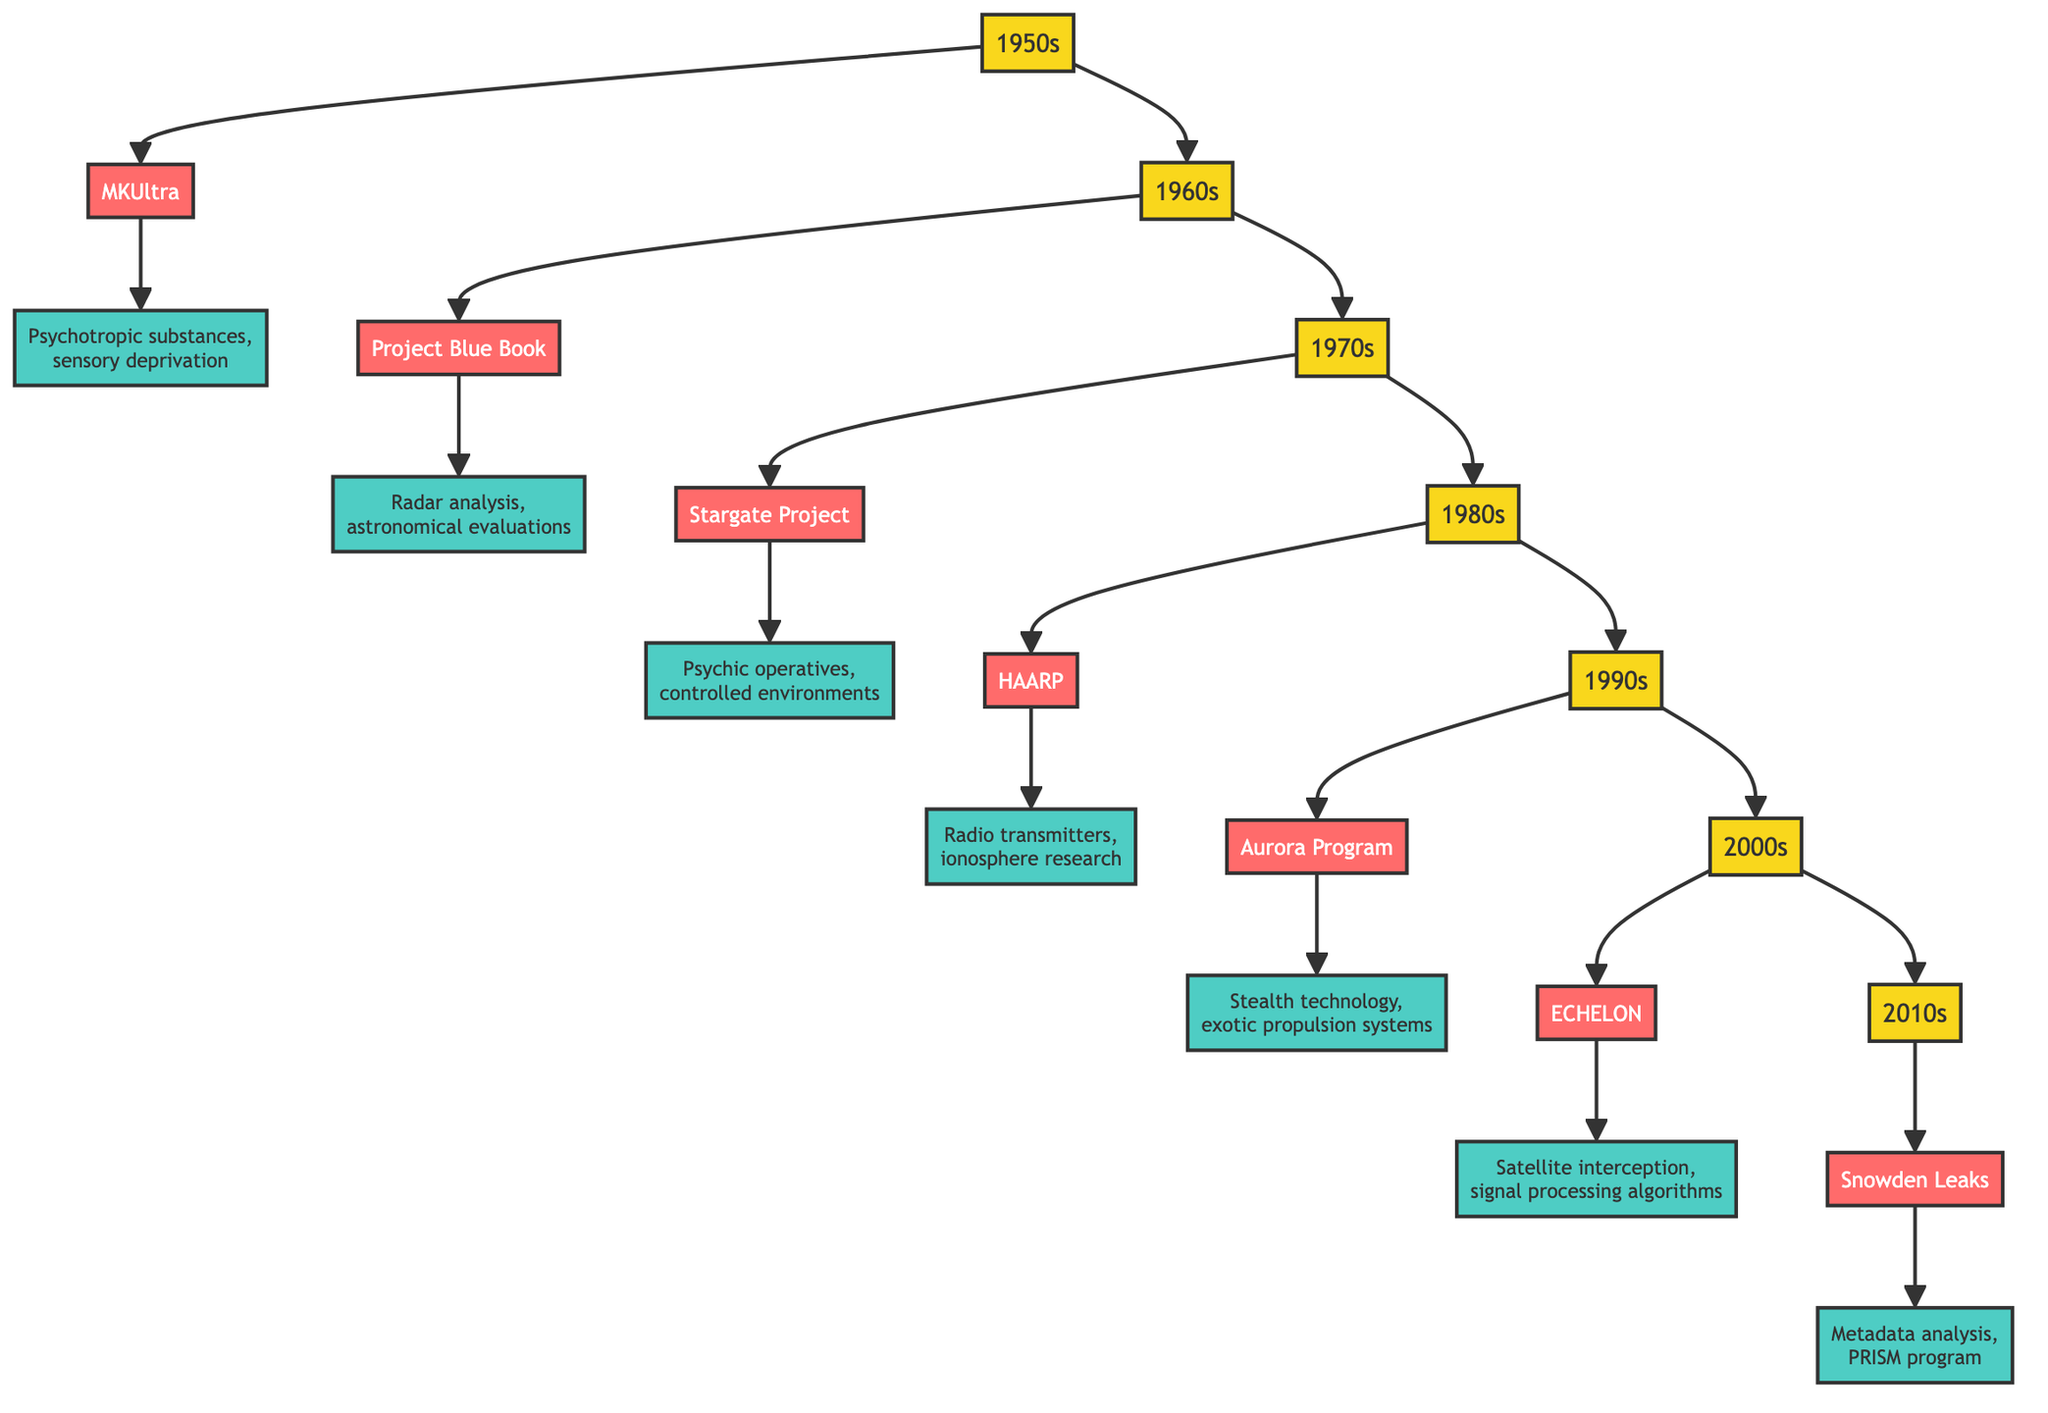What project was associated with the 1960s? The diagram shows that the node representing the 1960s connects to the project node "Project Blue Book", indicating that this project is associated with that decade.
Answer: Project Blue Book How many decades are represented in the diagram? By counting the distinct decade nodes from 1950s to 2010s mentioned in the diagram, there are seven decade nodes present: 1950s, 1960s, 1970s, 1980s, 1990s, 2000s, and 2010s.
Answer: 7 Which project corresponds with the 1970s? The node labeled "1970s" points to "Stargate Project", indicating that this project corresponds with that decade.
Answer: Stargate Project What technology was used in the MKUltra project? The diagram indicates that the MKUltra project node links to the technology node detailing "Psychotropic substances, sensory deprivation", outlining what technologies were involved in this project.
Answer: Psychotropic substances, sensory deprivation Which project was involved with global surveillance? The node for the 2000s connects to "ECHELON", which is explicitly described as a global surveillance network, indicating that it is the project associated with this function.
Answer: ECHELON What is the last decade mentioned in the diagram? The diagram ends with the node for the 2010s, which is the last decade shown in the chronological flow of projects.
Answer: 2010s Which project investigates UFO sightings? The 1960s decade node leads to the project node "Project Blue Book", which is specifically described as an investigation into UFO sightings, therefore confirming this link.
Answer: Project Blue Book What type of technology was used during the Aurora Program? The Aurora Program connects to the technology description, which mentions "Stealth technology, exotic propulsion systems", defining the particular technologies utilized in this project.
Answer: Stealth technology, exotic propulsion systems 